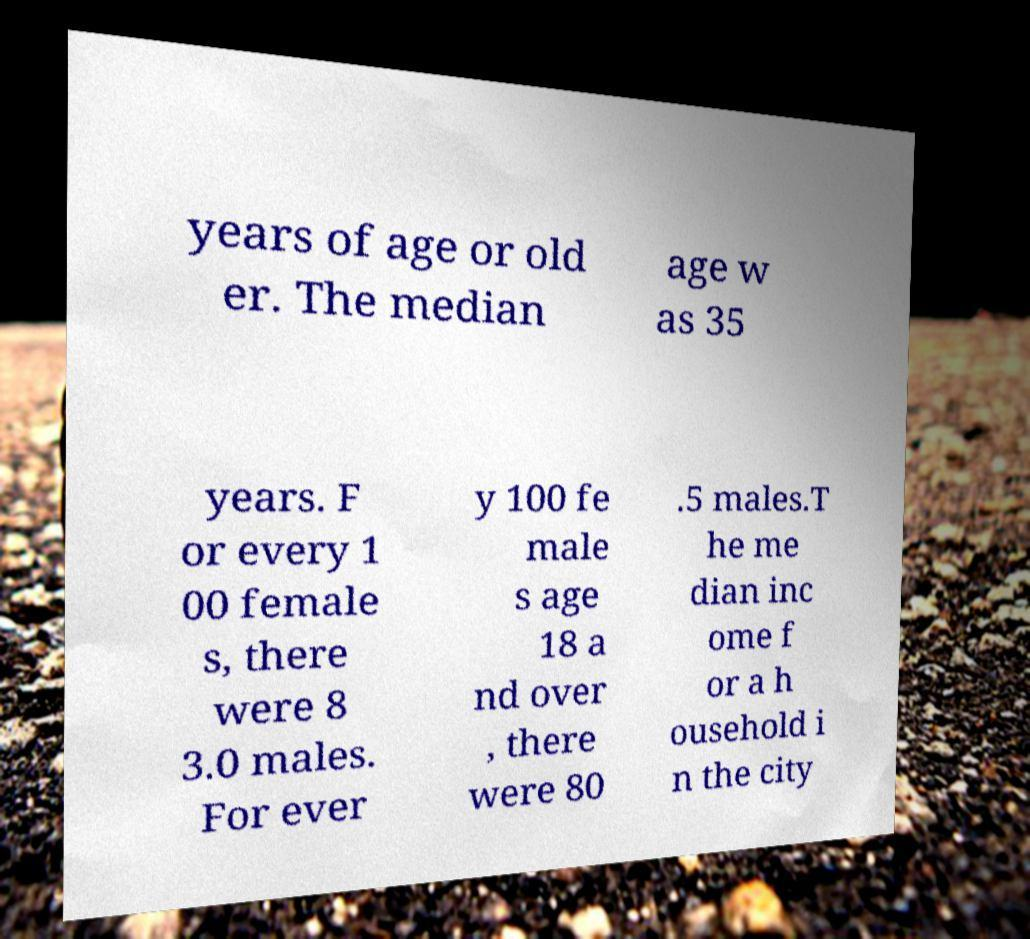Please identify and transcribe the text found in this image. years of age or old er. The median age w as 35 years. F or every 1 00 female s, there were 8 3.0 males. For ever y 100 fe male s age 18 a nd over , there were 80 .5 males.T he me dian inc ome f or a h ousehold i n the city 